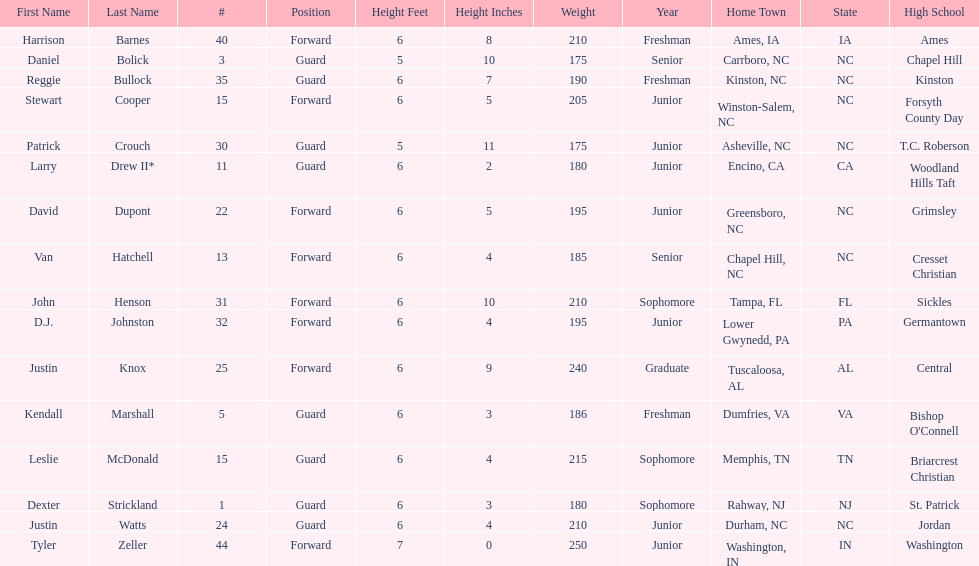Tallest player on the team Tyler Zeller. 